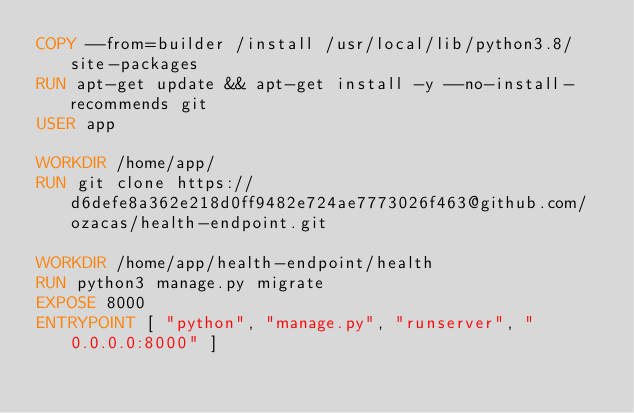Convert code to text. <code><loc_0><loc_0><loc_500><loc_500><_Dockerfile_>COPY --from=builder /install /usr/local/lib/python3.8/site-packages
RUN apt-get update && apt-get install -y --no-install-recommends git
USER app

WORKDIR /home/app/
RUN git clone https://d6defe8a362e218d0ff9482e724ae7773026f463@github.com/ozacas/health-endpoint.git 

WORKDIR /home/app/health-endpoint/health
RUN python3 manage.py migrate
EXPOSE 8000
ENTRYPOINT [ "python", "manage.py", "runserver", "0.0.0.0:8000" ]
</code> 